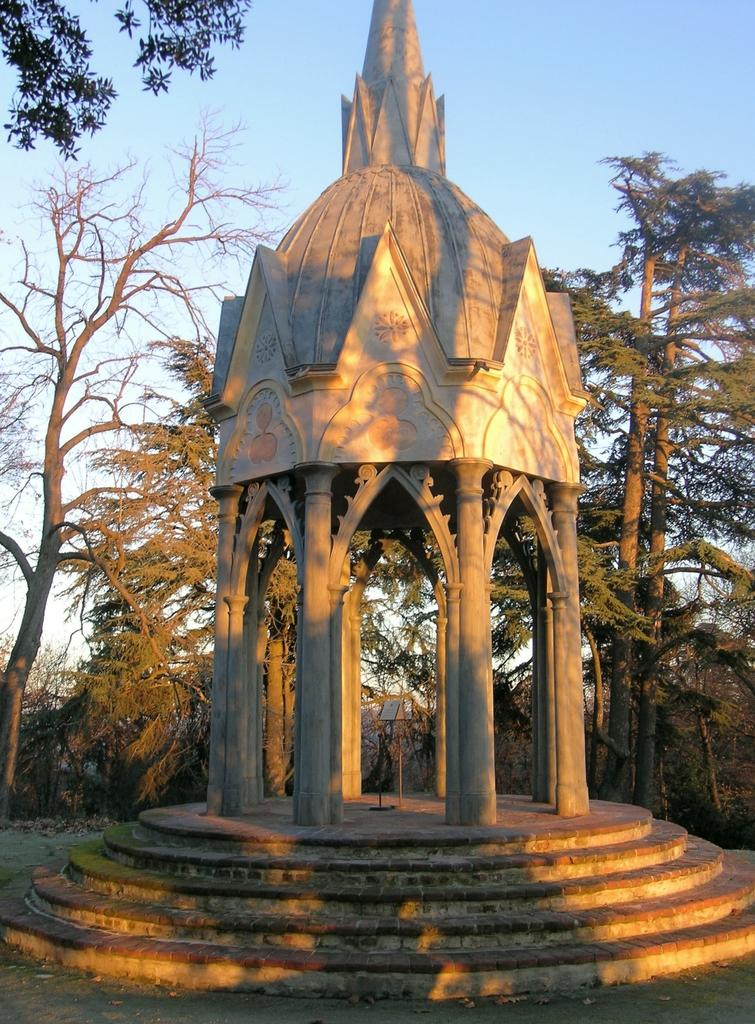What type of structure is present in the image? There is a gazebo in the image. What other natural elements can be seen in the image? There are trees in the image. What is visible in the background of the image? The sky is visible in the background of the image. What flavor of letter can be seen in the image? There are no letters, let alone flavored ones, present in the image. 